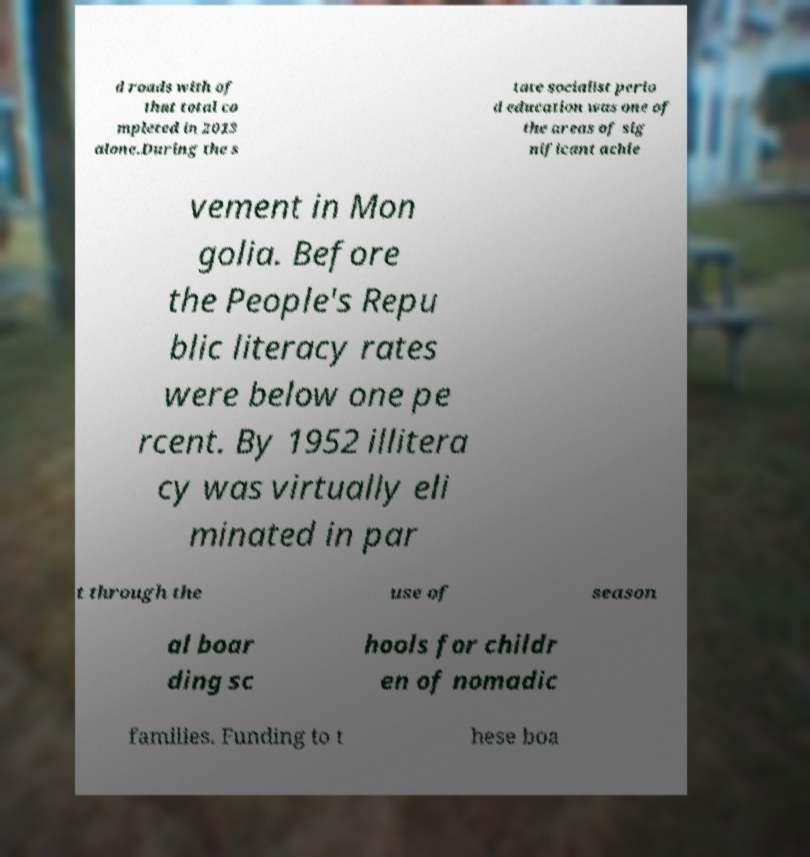There's text embedded in this image that I need extracted. Can you transcribe it verbatim? d roads with of that total co mpleted in 2013 alone.During the s tate socialist perio d education was one of the areas of sig nificant achie vement in Mon golia. Before the People's Repu blic literacy rates were below one pe rcent. By 1952 illitera cy was virtually eli minated in par t through the use of season al boar ding sc hools for childr en of nomadic families. Funding to t hese boa 